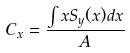<formula> <loc_0><loc_0><loc_500><loc_500>C _ { x } = \frac { \int x S _ { y } ( x ) d x } { A }</formula> 